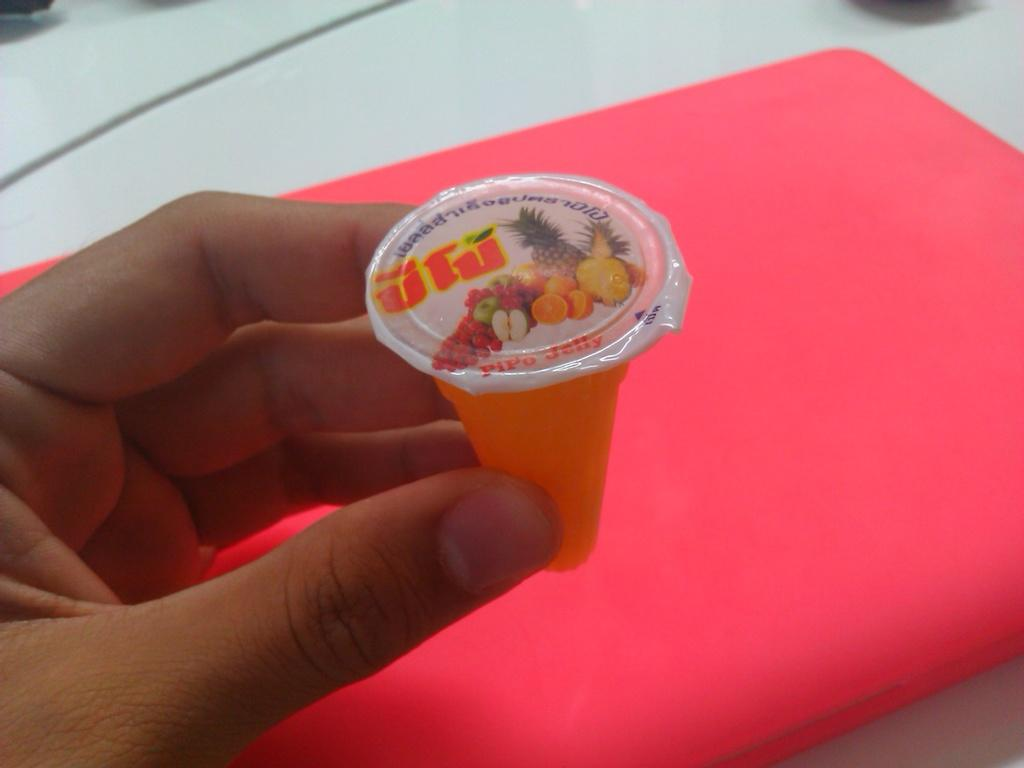What is the human hand in the image holding? The hand is holding a candy. What is the hand resting on in the image? The hand is resting on a table. What type of growth can be seen on the hand in the image? There is no visible growth on the hand in the image. 